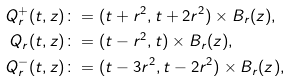<formula> <loc_0><loc_0><loc_500><loc_500>Q ^ { + } _ { r } ( t , z ) & \colon = ( t + r ^ { 2 } , t + 2 r ^ { 2 } ) \times B _ { r } ( z ) , \\ Q _ { r } ( t , z ) & \colon = ( t - r ^ { 2 } , t ) \times B _ { r } ( z ) , \\ Q ^ { - } _ { r } ( t , z ) & \colon = ( t - 3 r ^ { 2 } , t - 2 r ^ { 2 } ) \times B _ { r } ( z ) ,</formula> 